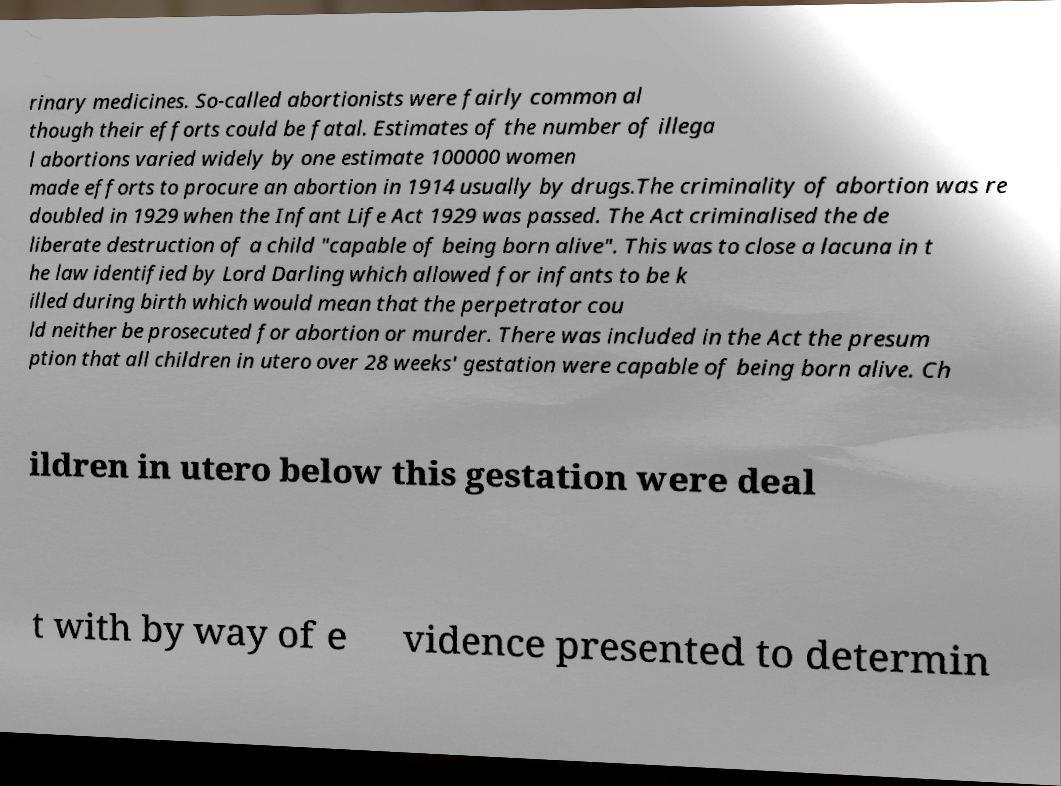Please identify and transcribe the text found in this image. rinary medicines. So-called abortionists were fairly common al though their efforts could be fatal. Estimates of the number of illega l abortions varied widely by one estimate 100000 women made efforts to procure an abortion in 1914 usually by drugs.The criminality of abortion was re doubled in 1929 when the Infant Life Act 1929 was passed. The Act criminalised the de liberate destruction of a child "capable of being born alive". This was to close a lacuna in t he law identified by Lord Darling which allowed for infants to be k illed during birth which would mean that the perpetrator cou ld neither be prosecuted for abortion or murder. There was included in the Act the presum ption that all children in utero over 28 weeks' gestation were capable of being born alive. Ch ildren in utero below this gestation were deal t with by way of e vidence presented to determin 